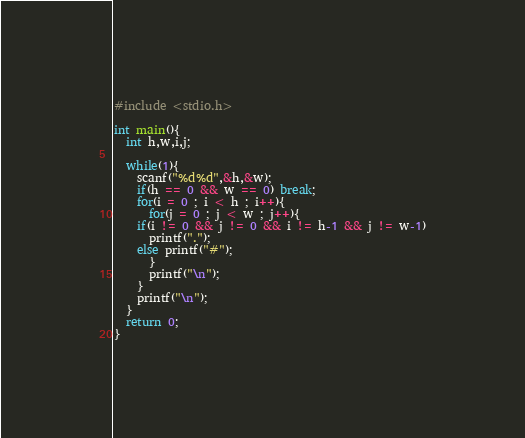Convert code to text. <code><loc_0><loc_0><loc_500><loc_500><_C_>#include <stdio.h>

int main(){
  int h,w,i,j;

  while(1){
    scanf("%d%d",&h,&w);
    if(h == 0 && w == 0) break;
    for(i = 0 ; i < h ; i++){
      for(j = 0 ; j < w ; j++){
	if(i != 0 && j != 0 && i != h-1 && j != w-1)
	  printf(".");
	else printf("#");
      }
      printf("\n");
    }
    printf("\n");
  }
  return 0;
}</code> 